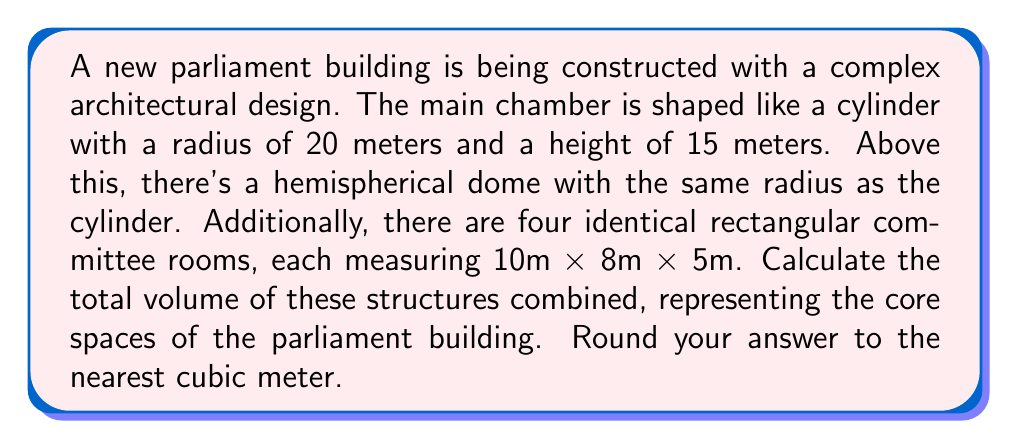Help me with this question. To solve this problem, we need to calculate the volumes of different geometric shapes and sum them up:

1. Volume of the cylindrical main chamber:
   $$V_{cylinder} = \pi r^2 h$$
   $$V_{cylinder} = \pi \cdot 20^2 \cdot 15 = 18,849.56 \text{ m}^3$$

2. Volume of the hemispherical dome:
   $$V_{hemisphere} = \frac{2}{3}\pi r^3$$
   $$V_{hemisphere} = \frac{2}{3}\pi \cdot 20^3 = 16,755.16 \text{ m}^3$$

3. Volume of one rectangular committee room:
   $$V_{room} = l \cdot w \cdot h$$
   $$V_{room} = 10 \cdot 8 \cdot 5 = 400 \text{ m}^3$$

4. Total volume of four identical committee rooms:
   $$V_{rooms} = 4 \cdot 400 = 1,600 \text{ m}^3$$

5. Sum up all volumes:
   $$V_{total} = V_{cylinder} + V_{hemisphere} + V_{rooms}$$
   $$V_{total} = 18,849.56 + 16,755.16 + 1,600 = 37,204.72 \text{ m}^3$$

6. Round to the nearest cubic meter:
   $$V_{total} \approx 37,205 \text{ m}^3$$
Answer: 37,205 m³ 